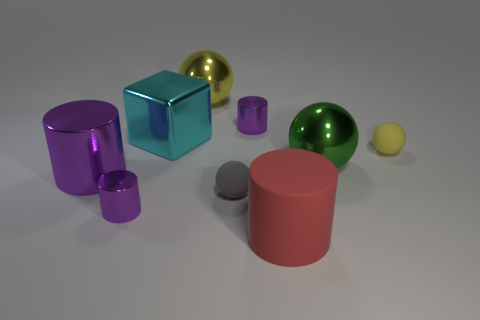There is a big purple thing that is the same shape as the red matte thing; what material is it?
Offer a terse response. Metal. What size is the yellow object on the left side of the large red cylinder?
Ensure brevity in your answer.  Large. Are there any small cyan cubes that have the same material as the large yellow sphere?
Your answer should be very brief. No. There is a tiny shiny cylinder behind the small yellow ball; is its color the same as the big matte object?
Your response must be concise. No. Are there an equal number of large green balls that are in front of the gray thing and large cylinders?
Your answer should be compact. No. Is there a large object that has the same color as the block?
Your answer should be very brief. No. Is the red rubber cylinder the same size as the gray ball?
Offer a terse response. No. There is a purple object on the right side of the small shiny thing on the left side of the cyan metallic thing; what size is it?
Provide a short and direct response. Small. What is the size of the ball that is both in front of the large yellow metal thing and behind the green shiny ball?
Your answer should be very brief. Small. How many purple metal things have the same size as the gray matte object?
Your answer should be compact. 2. 